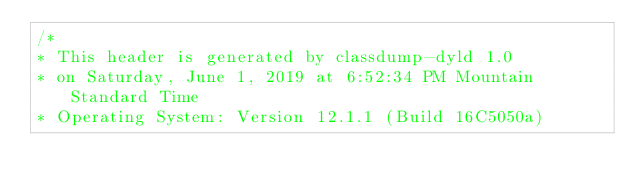Convert code to text. <code><loc_0><loc_0><loc_500><loc_500><_C_>/*
* This header is generated by classdump-dyld 1.0
* on Saturday, June 1, 2019 at 6:52:34 PM Mountain Standard Time
* Operating System: Version 12.1.1 (Build 16C5050a)</code> 